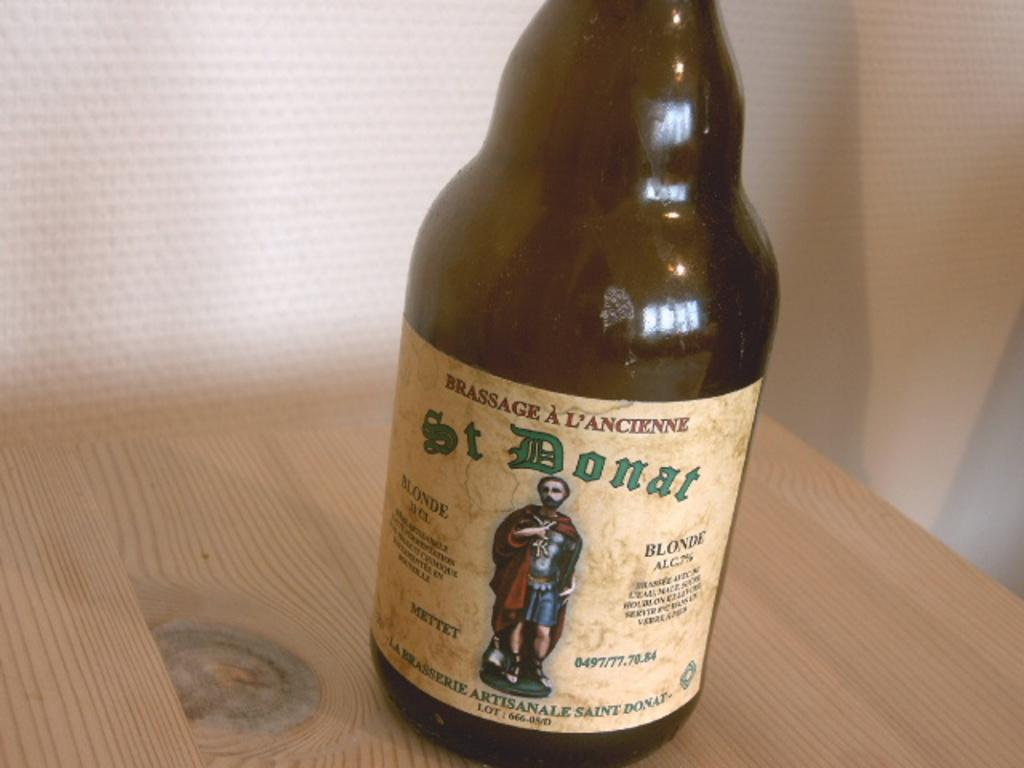<image>
Offer a succinct explanation of the picture presented. the word donat is on the beer bottle 